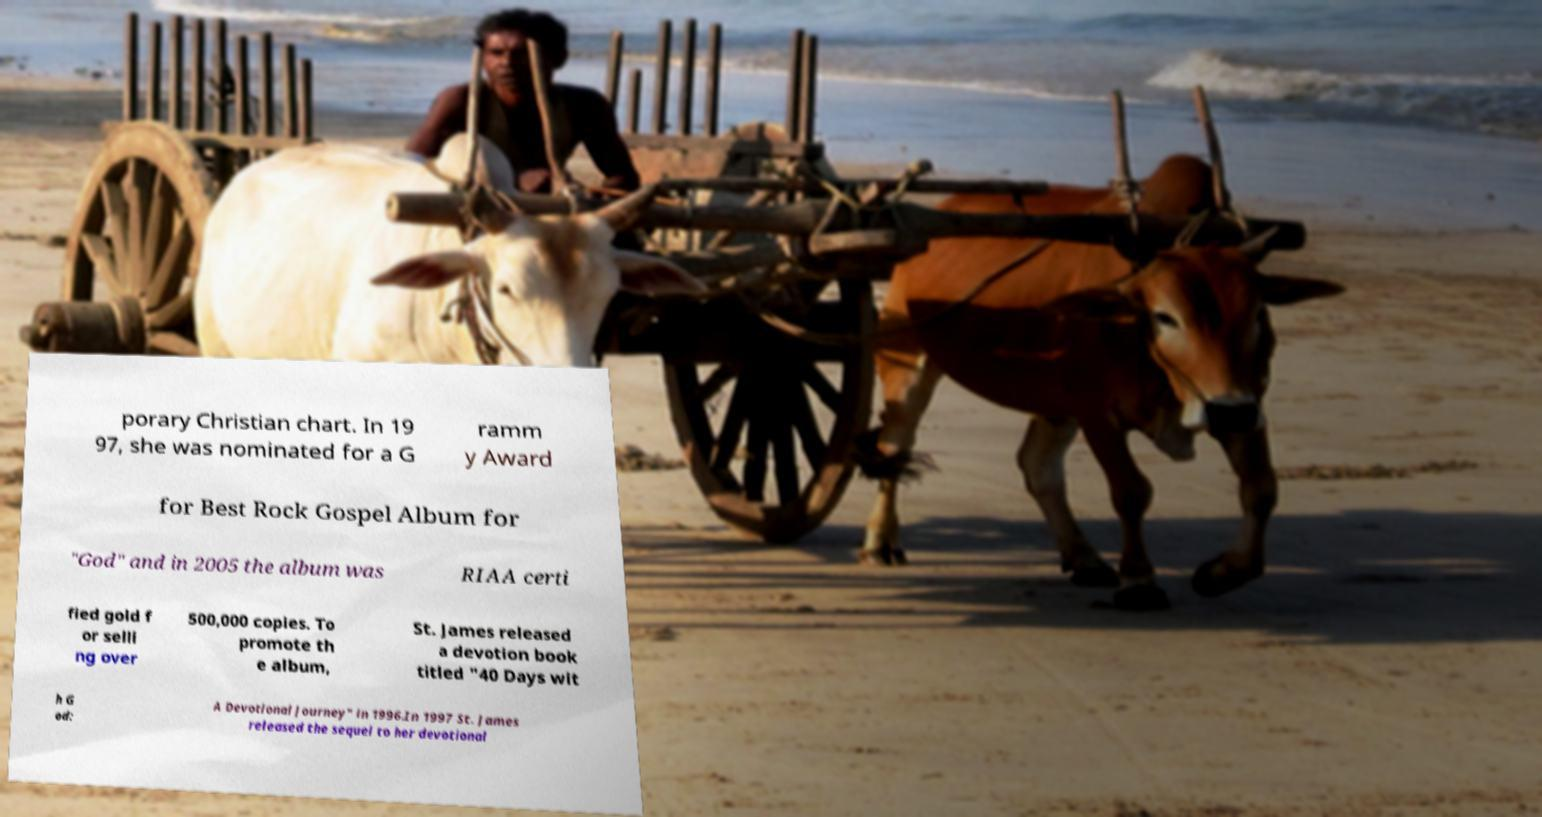What messages or text are displayed in this image? I need them in a readable, typed format. porary Christian chart. In 19 97, she was nominated for a G ramm y Award for Best Rock Gospel Album for "God" and in 2005 the album was RIAA certi fied gold f or selli ng over 500,000 copies. To promote th e album, St. James released a devotion book titled "40 Days wit h G od: A Devotional Journey" in 1996.In 1997 St. James released the sequel to her devotional 